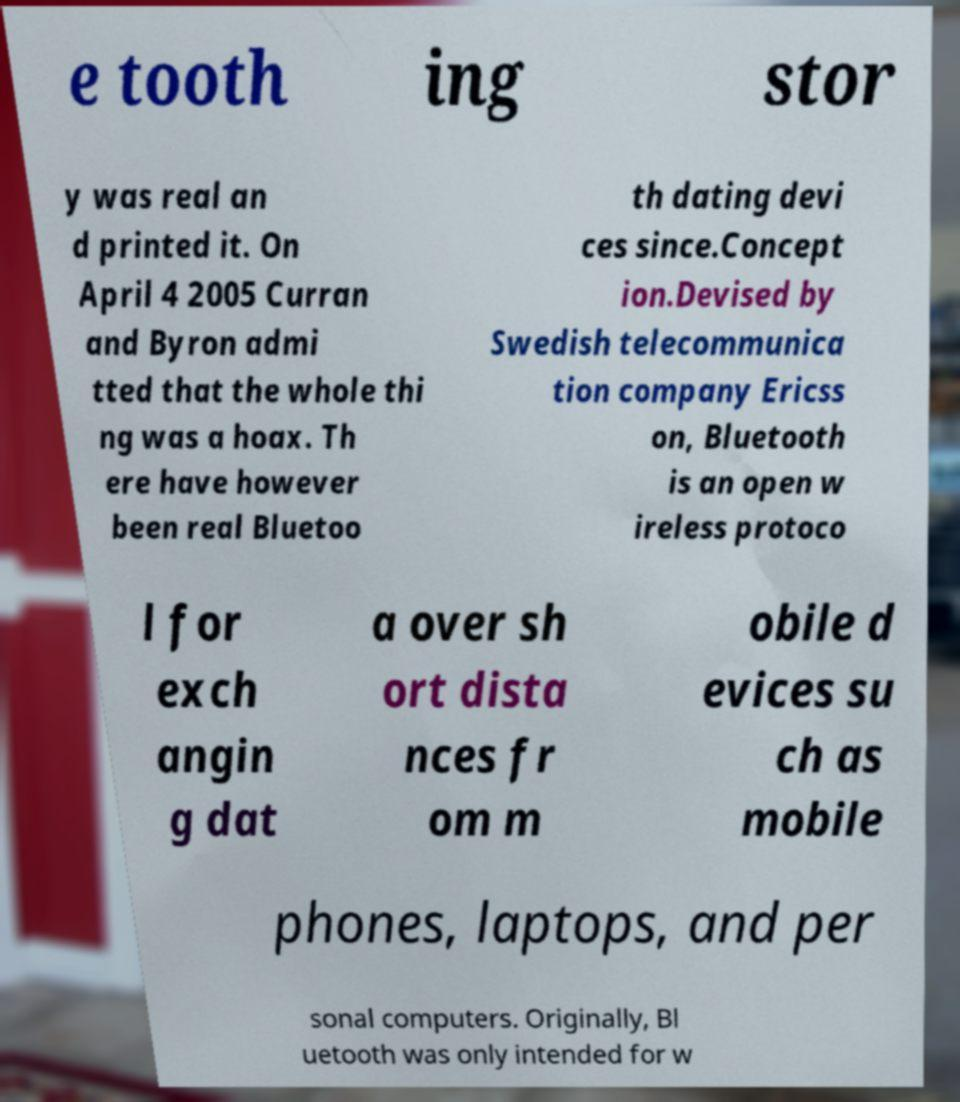I need the written content from this picture converted into text. Can you do that? e tooth ing stor y was real an d printed it. On April 4 2005 Curran and Byron admi tted that the whole thi ng was a hoax. Th ere have however been real Bluetoo th dating devi ces since.Concept ion.Devised by Swedish telecommunica tion company Ericss on, Bluetooth is an open w ireless protoco l for exch angin g dat a over sh ort dista nces fr om m obile d evices su ch as mobile phones, laptops, and per sonal computers. Originally, Bl uetooth was only intended for w 